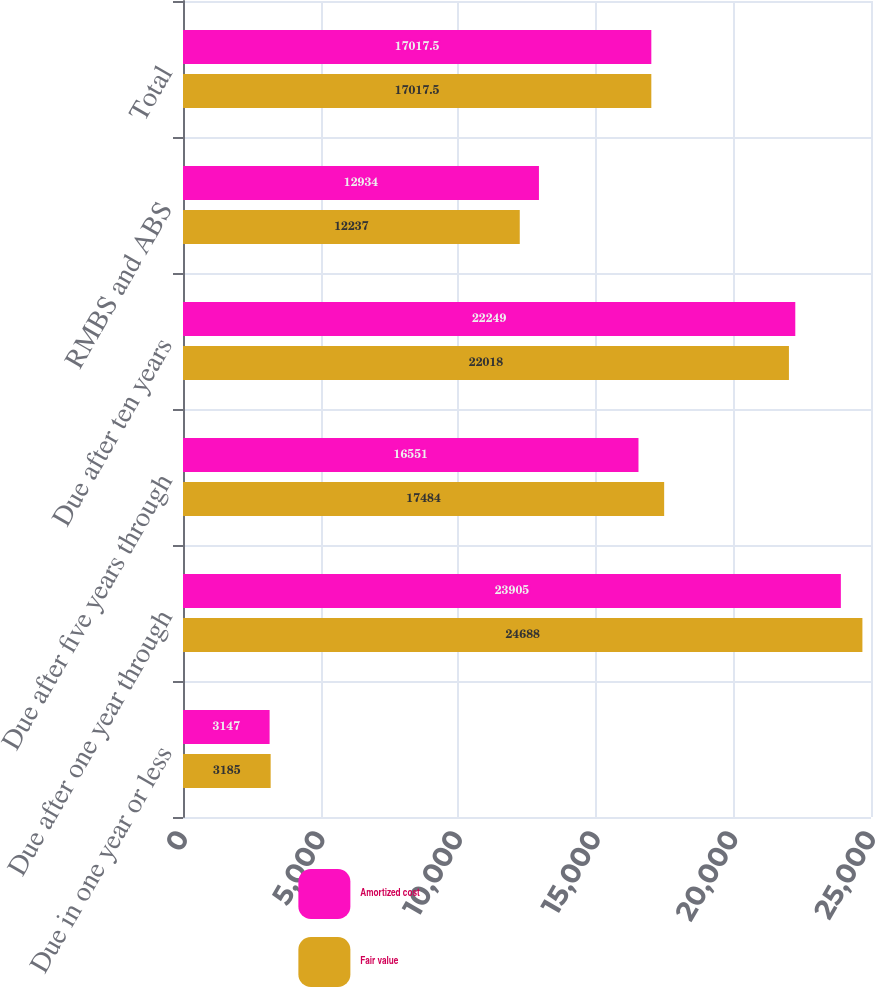Convert chart to OTSL. <chart><loc_0><loc_0><loc_500><loc_500><stacked_bar_chart><ecel><fcel>Due in one year or less<fcel>Due after one year through<fcel>Due after five years through<fcel>Due after ten years<fcel>RMBS and ABS<fcel>Total<nl><fcel>Amortized cost<fcel>3147<fcel>23905<fcel>16551<fcel>22249<fcel>12934<fcel>17017.5<nl><fcel>Fair value<fcel>3185<fcel>24688<fcel>17484<fcel>22018<fcel>12237<fcel>17017.5<nl></chart> 